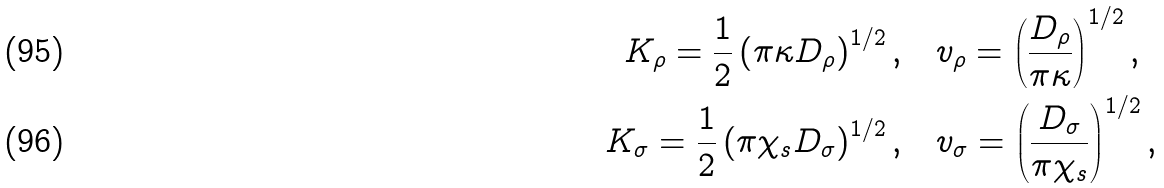Convert formula to latex. <formula><loc_0><loc_0><loc_500><loc_500>K _ { \rho } = \frac { 1 } { 2 } \left ( \pi \kappa D _ { \rho } \right ) ^ { 1 / 2 } , & \quad v _ { \rho } = \left ( \frac { D _ { \rho } } { \pi \kappa } \right ) ^ { 1 / 2 } , \\ K _ { \sigma } = \frac { 1 } { 2 } \left ( \pi \chi _ { s } D _ { \sigma } \right ) ^ { 1 / 2 } , & \quad v _ { \sigma } = \left ( \frac { D _ { \sigma } } { \pi \chi _ { s } } \right ) ^ { 1 / 2 } ,</formula> 